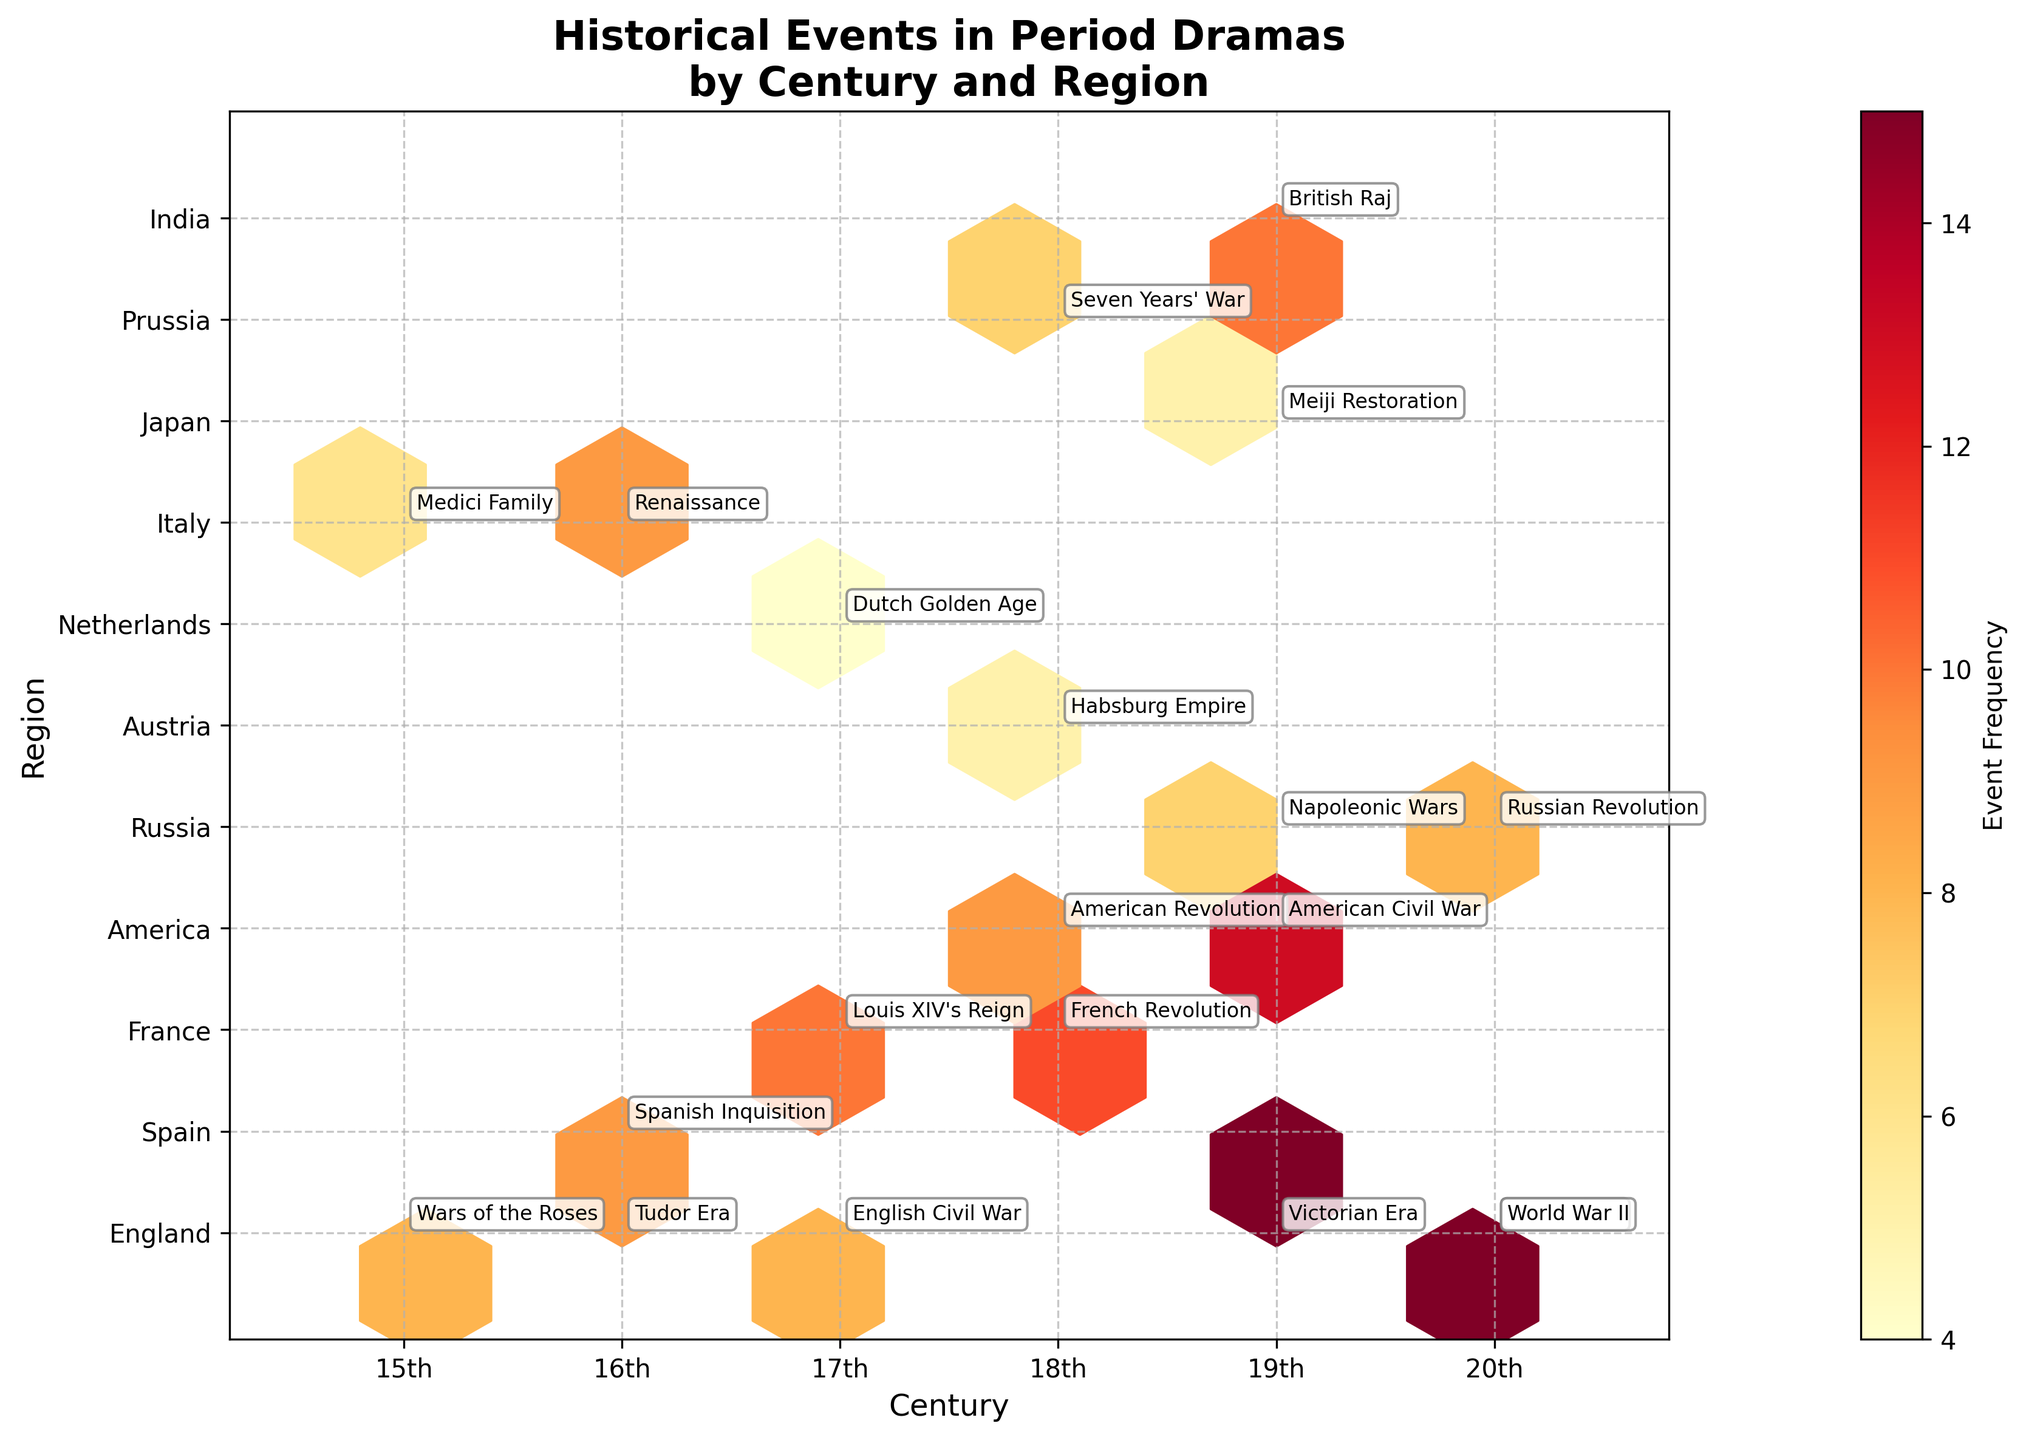How many regions are represented in the plot? We need to count the unique regions listed on the y-axis. The regions are England, Spain, France, America, Russia, Austria, Netherlands, Italy, Japan, Prussia, and India.
Answer: 11 Which century has the highest event frequency for England? We need to look at the hexbin plot and find the century with the darkest hexbin (indicating the highest frequency) for the y-axis position corresponding to England. The 20th century has the darkest hexbin for England.
Answer: 20th In which region and century did the Medici Family event occur? We need to locate the hexbin marked with the text "Medici Family." The plot shows this event in the 15th century and in the region labeled as Italy.
Answer: Italy, 15th Compare the frequency of events for the American Revolution and the French Revolution. Which one is more frequently referenced? Look for the hexagons labeled "American Revolution" and "French Revolution" and compare their colors or frequency values. The American Revolution has a frequency of 9, while the French Revolution has a frequency of 11.
Answer: French Revolution What is the combined frequency of historical events referenced in period dramas for the 19th century? Identify and sum up the frequencies of events tagged in the 19th century: Victorian Era (15), Napoleonic Wars (7), American Civil War (13), Meiji Restoration (5), and British Raj (10). The total is 15 + 7 + 13 + 5 + 10 = 50.
Answer: 50 Which region has the most historical events referenced from the 18th century? Look at the hexbin plot for the 18th century and identify which y-axis region position has the most hexagons. The regions with events in the 18th century are America (9), France (11), Austria (5), and Prussia (7). France has the highest frequency of 11.
Answer: France Is the occurrence of events in Russia more frequent in the 19th or 20th century? Find the hexagons labeled with Russian events in the 19th and 20th centuries. For the 19th century, the frequency is 7, and for the 20th century, the frequency is 8.
Answer: 20th Which century has the least amount of total event frequency? Sum the frequencies of all events for each century and find the lowest total. 15th: 14, 16th: 27, 17th: 22, 18th: 32, 19th: 50, 20th: 38. The 15th century has the lowest total frequency.
Answer: 15th What are the events mentioned for the 17th century across all regions? Look for all the text annotations in the plot for the 17th century and list them. The events are Louis XIV's Reign, Dutch Golden Age, English Civil War.
Answer: Louis XIV's Reign, Dutch Golden Age, English Civil War 